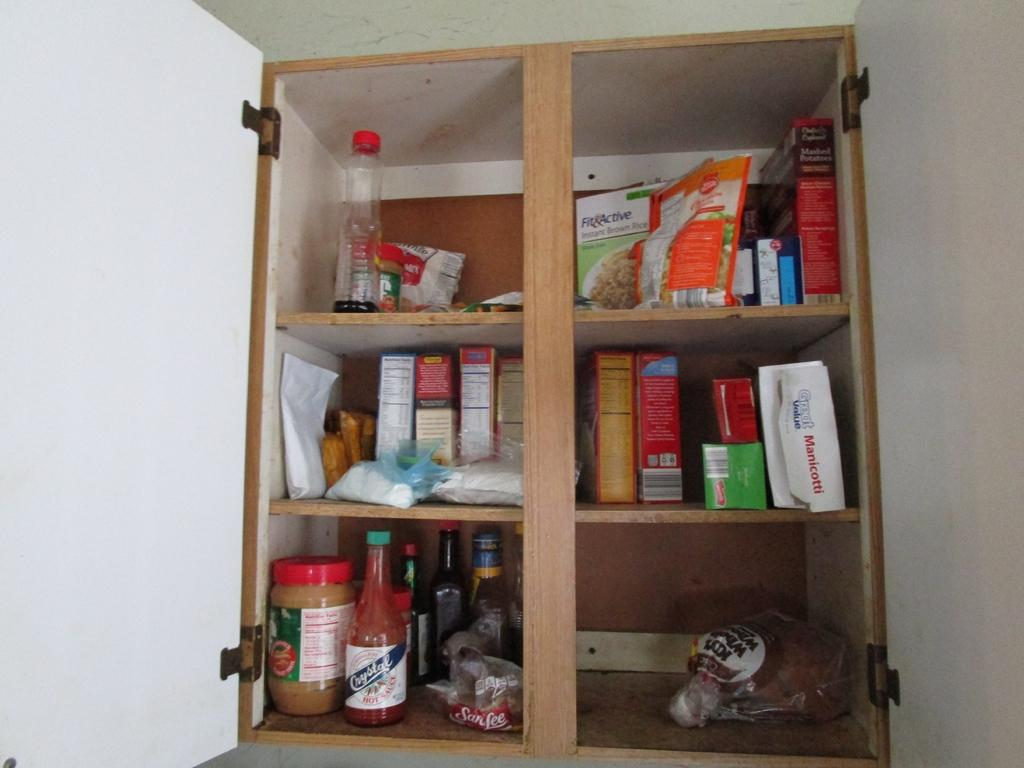<image>
Present a compact description of the photo's key features. A kitchen cabinet has a bottle of Crystal brand hot sauce on the bottom shelf. 